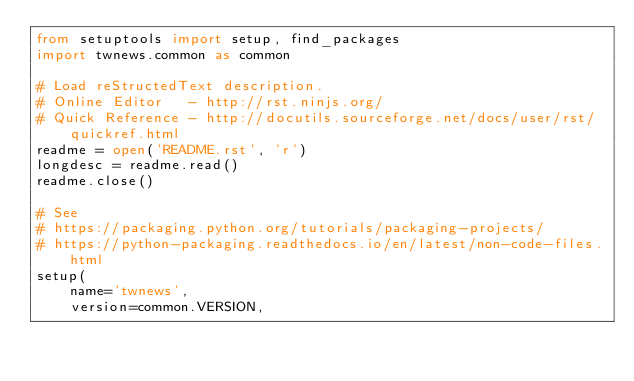<code> <loc_0><loc_0><loc_500><loc_500><_Python_>from setuptools import setup, find_packages
import twnews.common as common

# Load reStructedText description.
# Online Editor   - http://rst.ninjs.org/
# Quick Reference - http://docutils.sourceforge.net/docs/user/rst/quickref.html
readme = open('README.rst', 'r')
longdesc = readme.read()
readme.close()

# See
# https://packaging.python.org/tutorials/packaging-projects/
# https://python-packaging.readthedocs.io/en/latest/non-code-files.html
setup(
    name='twnews',
    version=common.VERSION,</code> 